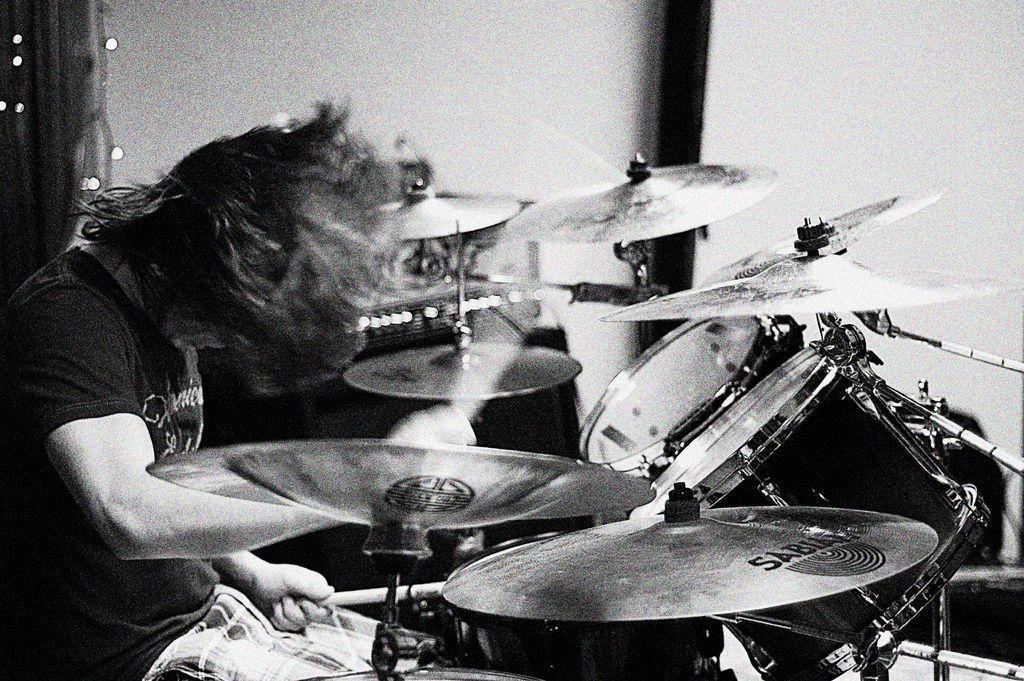Can you describe this image briefly? This is a black and white image. There is a person on the left side and the drum, drums in front of him. He is playing drums. 